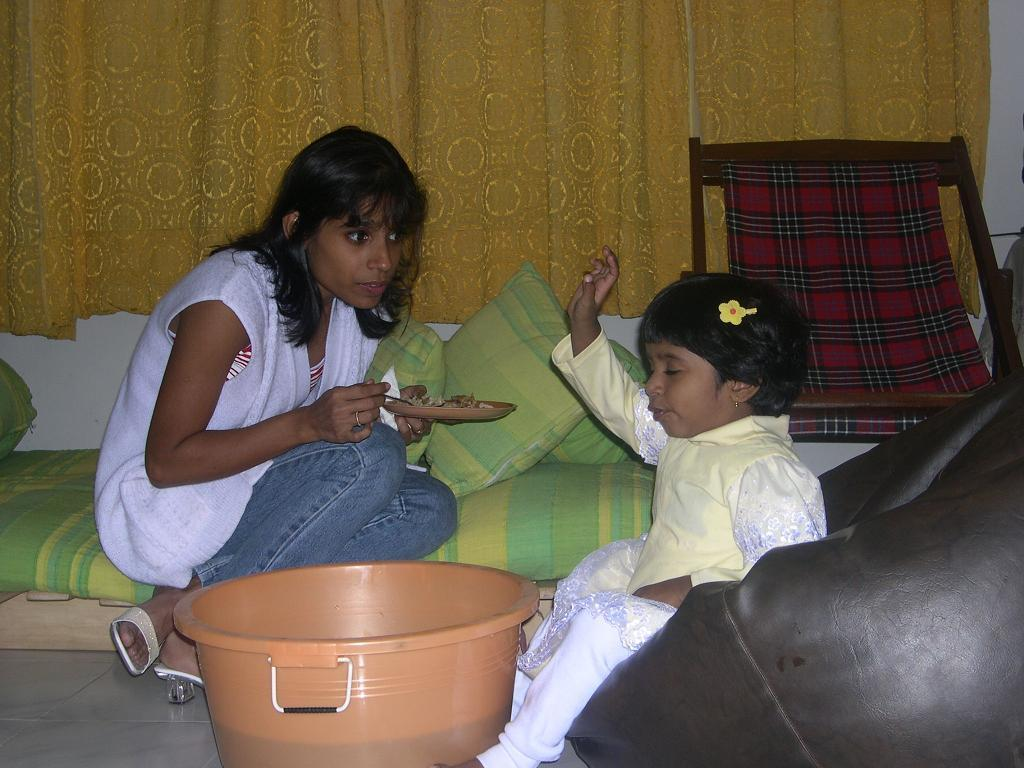What type of furniture is present in the image? There is a tub, a chair, and a bean bag in the image. What type of window treatment is visible in the image? There are curtains in the image. What is the woman holding in the image? The woman is holding a plate and a spoon in the image. Who is the woman looking at in the image? The woman is looking at a girl in the image. What is the girl sitting on in the image? The girl is sitting on a bean bag in the image. What type of decorative items are present in the image? There are pillows in the image. What advice does the root give to the girl in the image? There is no root present in the image, and therefore no advice can be given. 